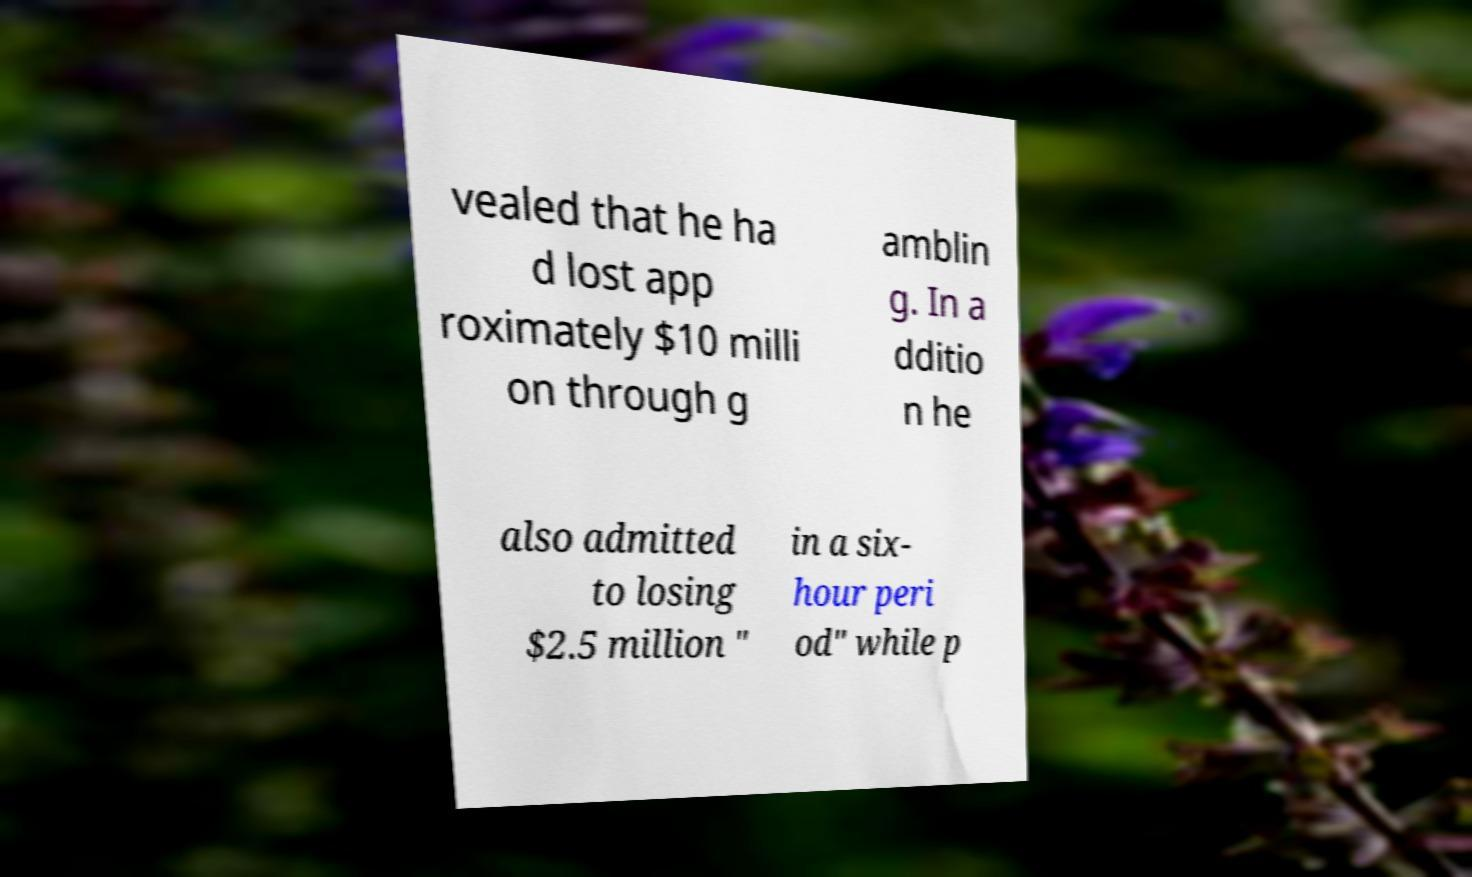Please identify and transcribe the text found in this image. vealed that he ha d lost app roximately $10 milli on through g amblin g. In a dditio n he also admitted to losing $2.5 million " in a six- hour peri od" while p 